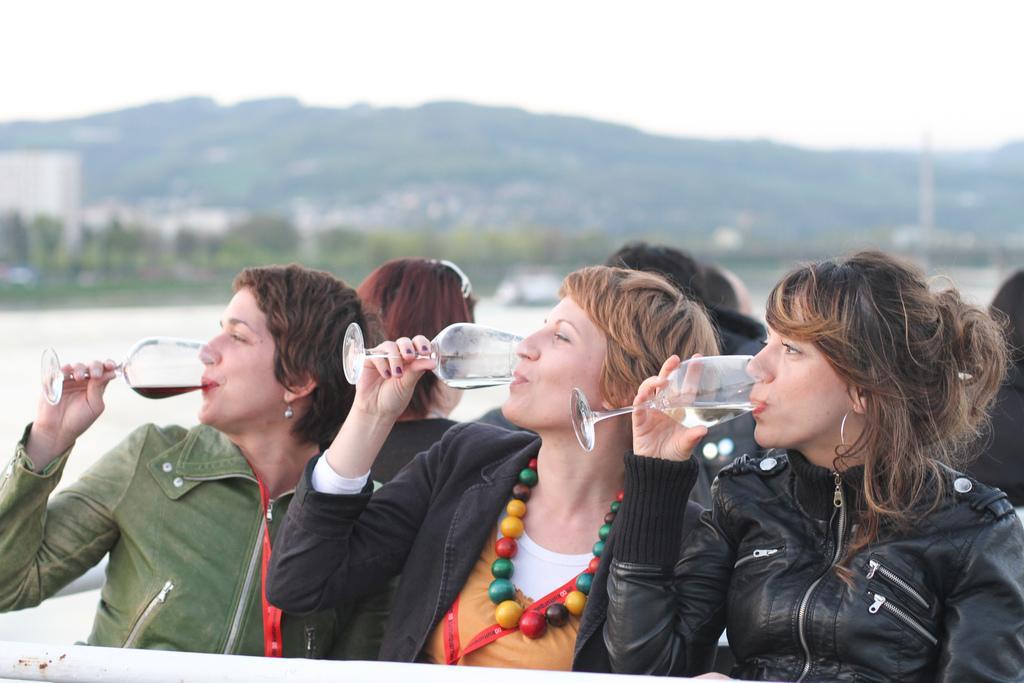Please provide a concise description of this image. This picture is clicked outside. In the foreground we can see the group of persons holding the glasses and drinking and seems to be sitting. In the background we can see the sky, hills, trees, group of persons and some other objects. 